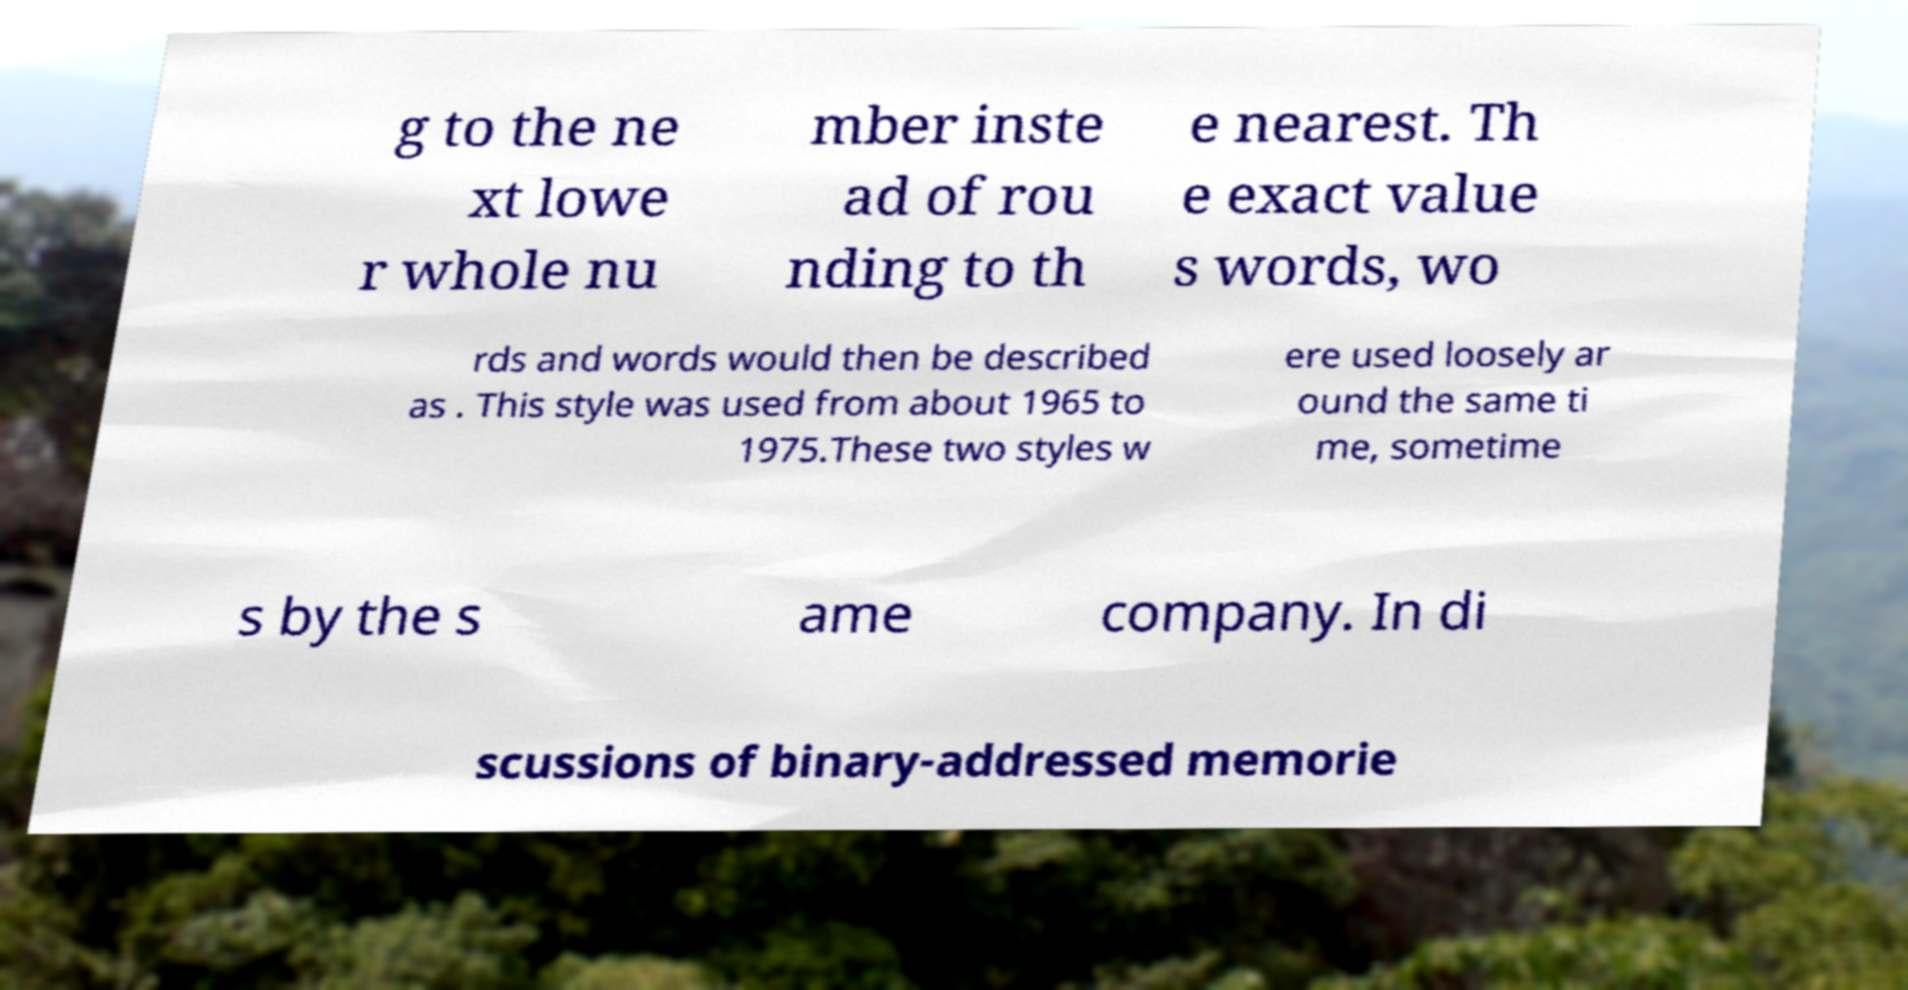Please read and relay the text visible in this image. What does it say? g to the ne xt lowe r whole nu mber inste ad of rou nding to th e nearest. Th e exact value s words, wo rds and words would then be described as . This style was used from about 1965 to 1975.These two styles w ere used loosely ar ound the same ti me, sometime s by the s ame company. In di scussions of binary-addressed memorie 